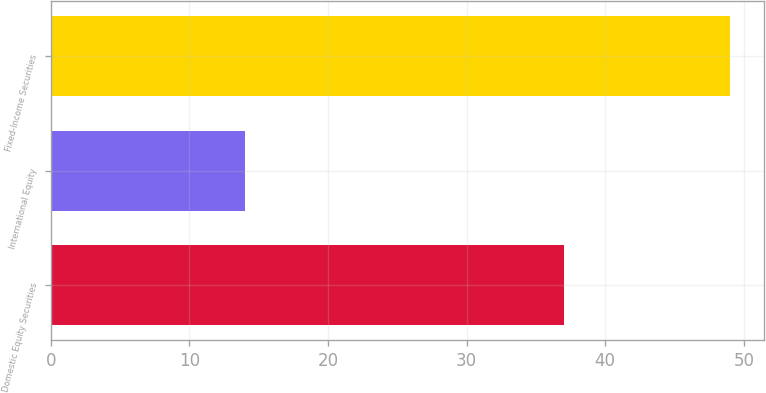Convert chart to OTSL. <chart><loc_0><loc_0><loc_500><loc_500><bar_chart><fcel>Domestic Equity Securities<fcel>International Equity<fcel>Fixed-Income Securities<nl><fcel>37<fcel>14<fcel>49<nl></chart> 